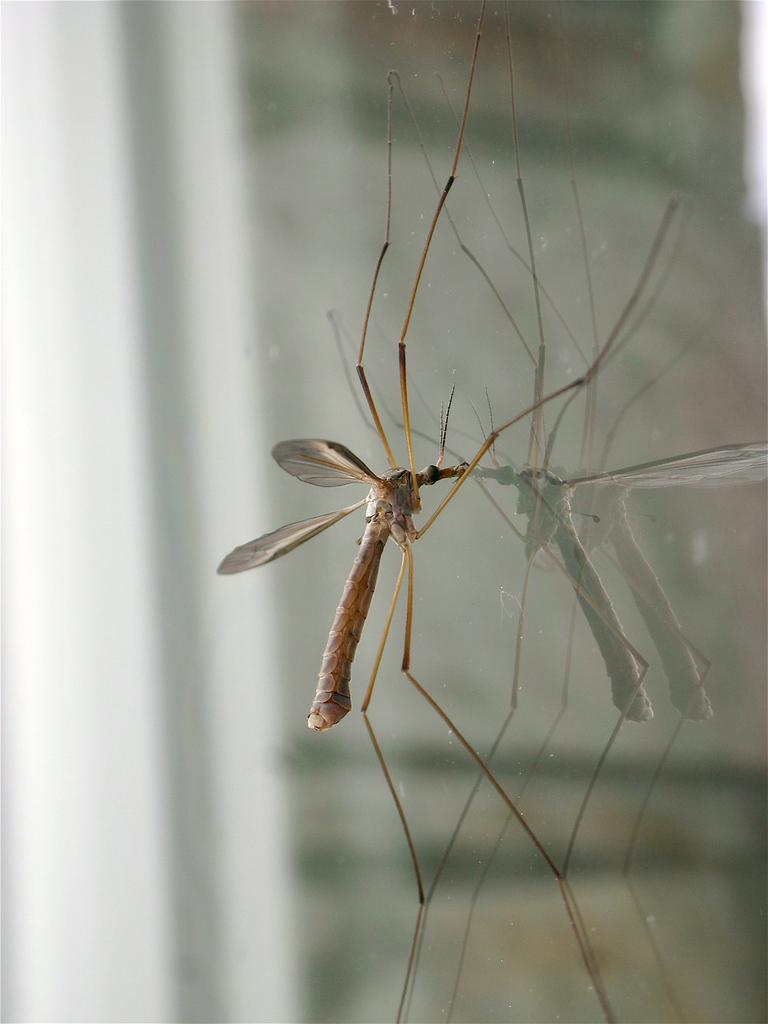What type of insect is present in the image? There is a mosquito in the image. What is the mosquito resting on in the image? The mosquito is on a class object. What type of calculator is visible in the image? There is no calculator present in the image; it only features a mosquito on a class object. 